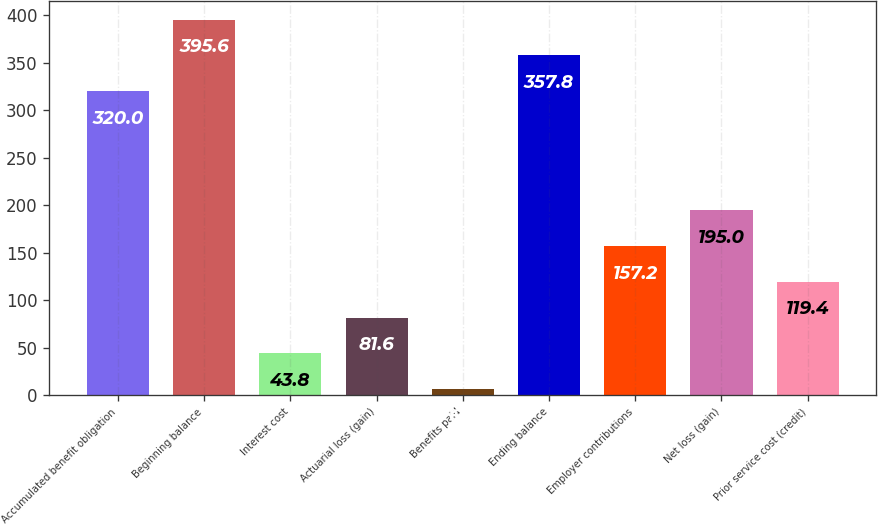Convert chart. <chart><loc_0><loc_0><loc_500><loc_500><bar_chart><fcel>Accumulated benefit obligation<fcel>Beginning balance<fcel>Interest cost<fcel>Actuarial loss (gain)<fcel>Benefits paid<fcel>Ending balance<fcel>Employer contributions<fcel>Net loss (gain)<fcel>Prior service cost (credit)<nl><fcel>320<fcel>395.6<fcel>43.8<fcel>81.6<fcel>6<fcel>357.8<fcel>157.2<fcel>195<fcel>119.4<nl></chart> 